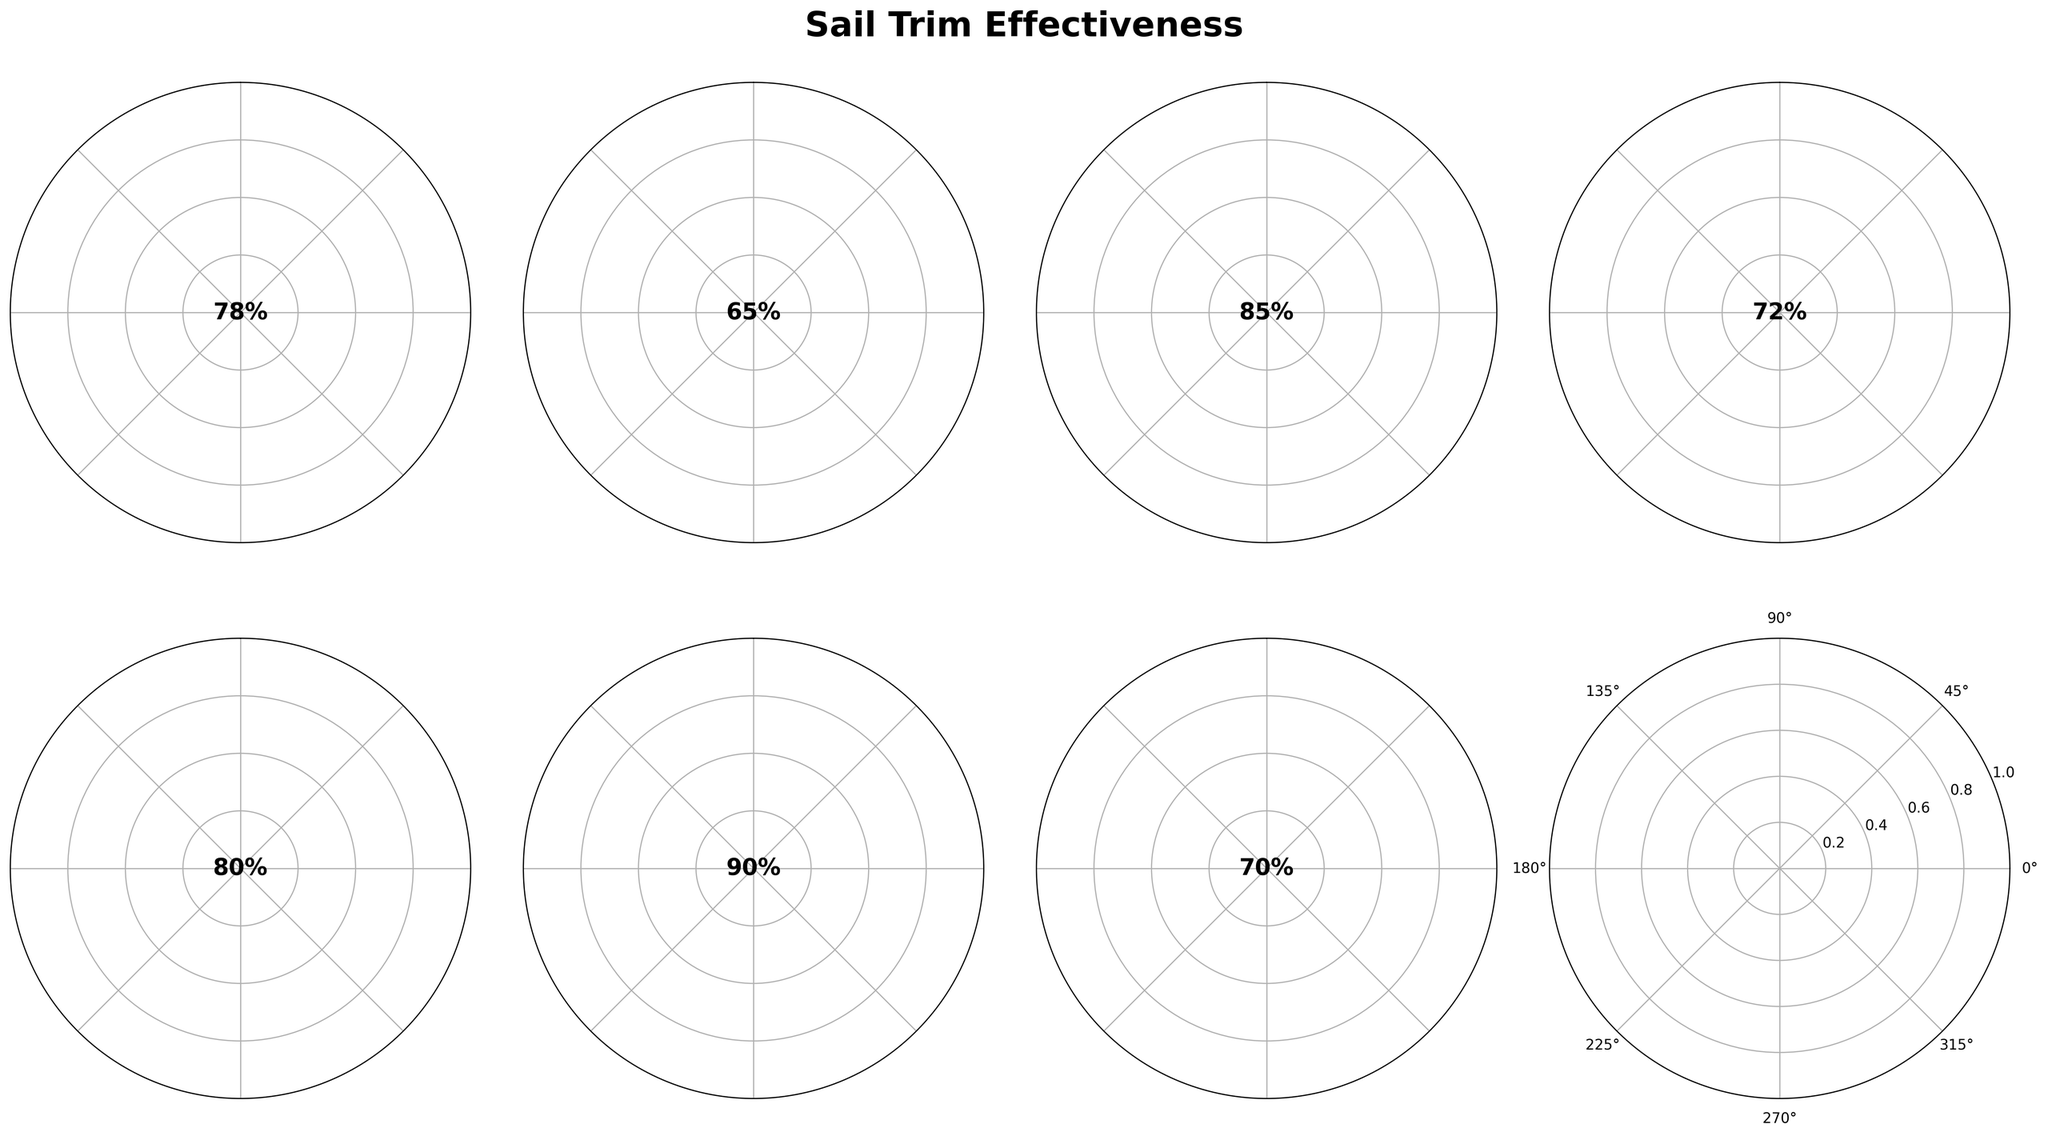What is the value for the Mainsail Trim? The Mainsail Trim value is displayed as a percentage in its gauge chart.
Answer: 78% What visual element indicates the Wind Power Utilization? The Wind Power Utilization is shown by a wedge with its corresponding percentage value at the center of the gauge chart.
Answer: 70% Which sail has the highest trim value? By comparing the values on all the gauges, identify the one with the highest percentage. The Spinnaker Trim has the highest value.
Answer: Spinnaker Trim What is the median value of all the trim effectiveness components? Arrange all values (78, 65, 85, 72, 80, 90, 70) in ascending order and find the middle value, which is 78 (median of 65, 70, 72, 78, 80, 85, 90).
Answer: 78% How does the Jib Trim compare to the Sheeting Angle? Compare the percentage values of the Jib Trim (65%) and Sheeting Angle (80%). The Jib Trim is lower than the Sheeting Angle.
Answer: Jib Trim is lower What is the average value of all gauges? Sum all the values (78 + 65 + 85 + 72 + 80 + 90 + 70 = 540) and divide by the number of gauges (7) to get the average (540/7 = 77.14).
Answer: 77.14% Which gauges have values below 75%? Identify gauges with values below 75%, which are Mainsail Trim (78%), Jib Trim (65%), Telltales Response (72%), and Wind Power Utilization (70%).
Answer: Jib Trim, Telltales Response, Wind Power Utilization What gauge shows the best response in sail trim effectiveness? Identify the gauge with the highest value, which is Sail Shape at 90%.
Answer: Sail Shape What is the difference between the highest and lowest values in the figure? The highest value is Sail Shape (90%) and the lowest is Jib Trim (65%). The difference is 90% - 65% = 25%.
Answer: 25% Does the Telltales Response indicate a higher or lower effectiveness than Wind Power Utilization? Compare their values, Telltales Response (72%) and Wind Power Utilization (70%). Telltales Response is higher.
Answer: Telltales Response is higher 